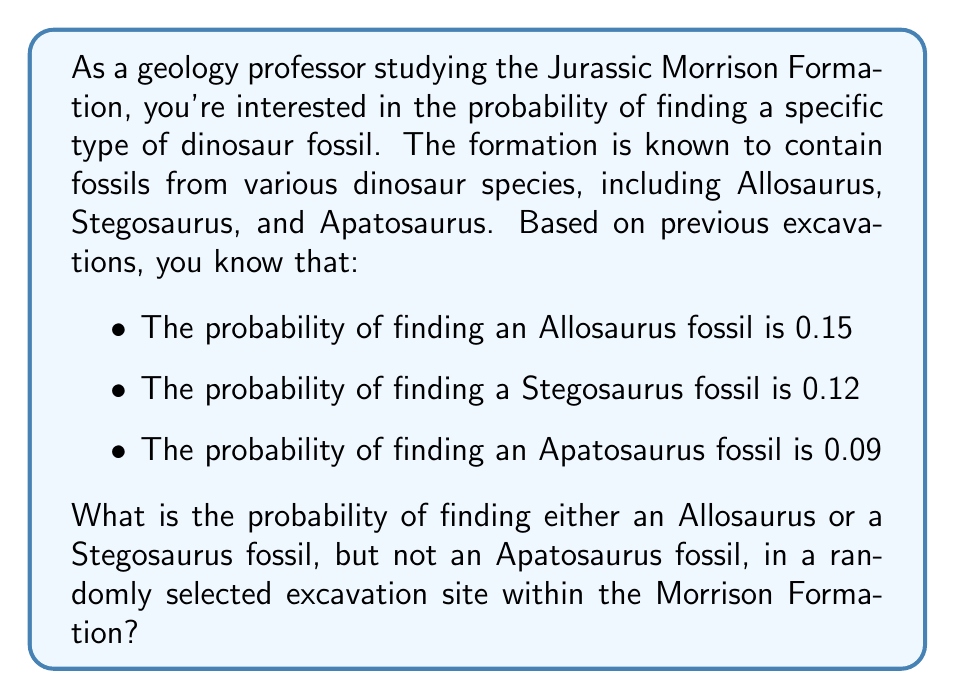Help me with this question. To solve this problem, we need to use the concepts of probability theory, specifically the addition rule and the complement rule. Let's break it down step by step:

1) Let's define our events:
   A: Finding an Allosaurus fossil
   S: Finding a Stegosaurus fossil
   P: Finding an Apatosaurus fossil

2) We're looking for the probability of (A or S) and (not P). In probability notation, this is:

   $P((A \cup S) \cap P^c)$

3) Using the multiplication rule for independent events, this can be rewritten as:

   $P(A \cup S) \cdot P(P^c)$

4) First, let's calculate $P(A \cup S)$. Using the addition rule:

   $P(A \cup S) = P(A) + P(S) - P(A \cap S)$

   We know $P(A) = 0.15$ and $P(S) = 0.12$. We don't know $P(A \cap S)$, but since finding one type of fossil doesn't affect the probability of finding another (they're independent events), we can multiply their individual probabilities:

   $P(A \cap S) = P(A) \cdot P(S) = 0.15 \cdot 0.12 = 0.018$

   So, $P(A \cup S) = 0.15 + 0.12 - 0.018 = 0.252$

5) Now, let's calculate $P(P^c)$. This is the probability of not finding an Apatosaurus fossil:

   $P(P^c) = 1 - P(P) = 1 - 0.09 = 0.91$

6) Finally, we can multiply these probabilities:

   $P((A \cup S) \cap P^c) = P(A \cup S) \cdot P(P^c) = 0.252 \cdot 0.91 = 0.22932$

Therefore, the probability of finding either an Allosaurus or a Stegosaurus fossil, but not an Apatosaurus fossil, is approximately 0.22932 or about 22.93%.
Answer: The probability is approximately 0.22932 or 22.93%. 